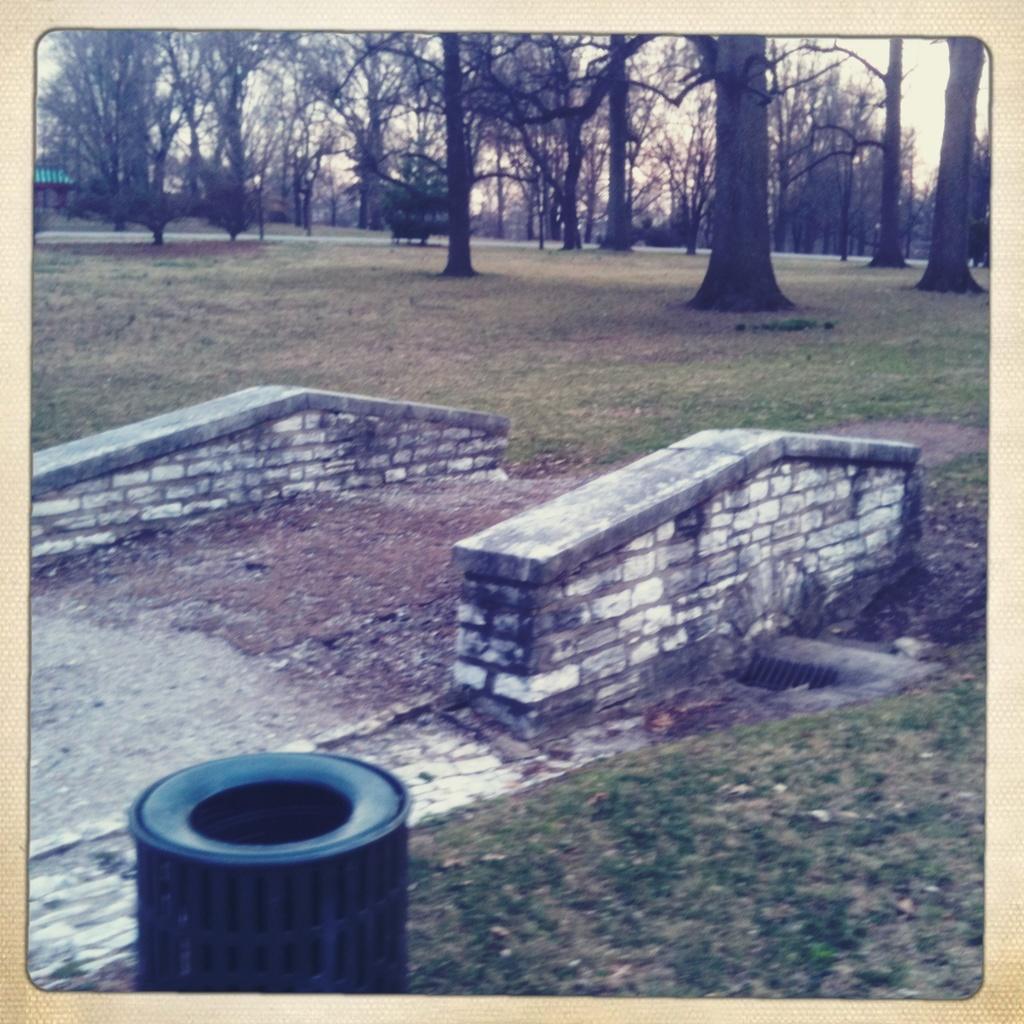Describe this image in one or two sentences. At the bottom of the image we can see a dustbin, in the background we can find grass and few trees. 